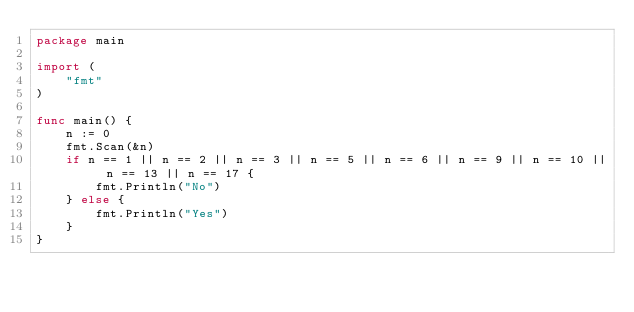<code> <loc_0><loc_0><loc_500><loc_500><_Go_>package main

import (
	"fmt"
)

func main() {
	n := 0
	fmt.Scan(&n)
	if n == 1 || n == 2 || n == 3 || n == 5 || n == 6 || n == 9 || n == 10 || n == 13 || n == 17 {
		fmt.Println("No")
	} else {
		fmt.Println("Yes")
	}
}
</code> 